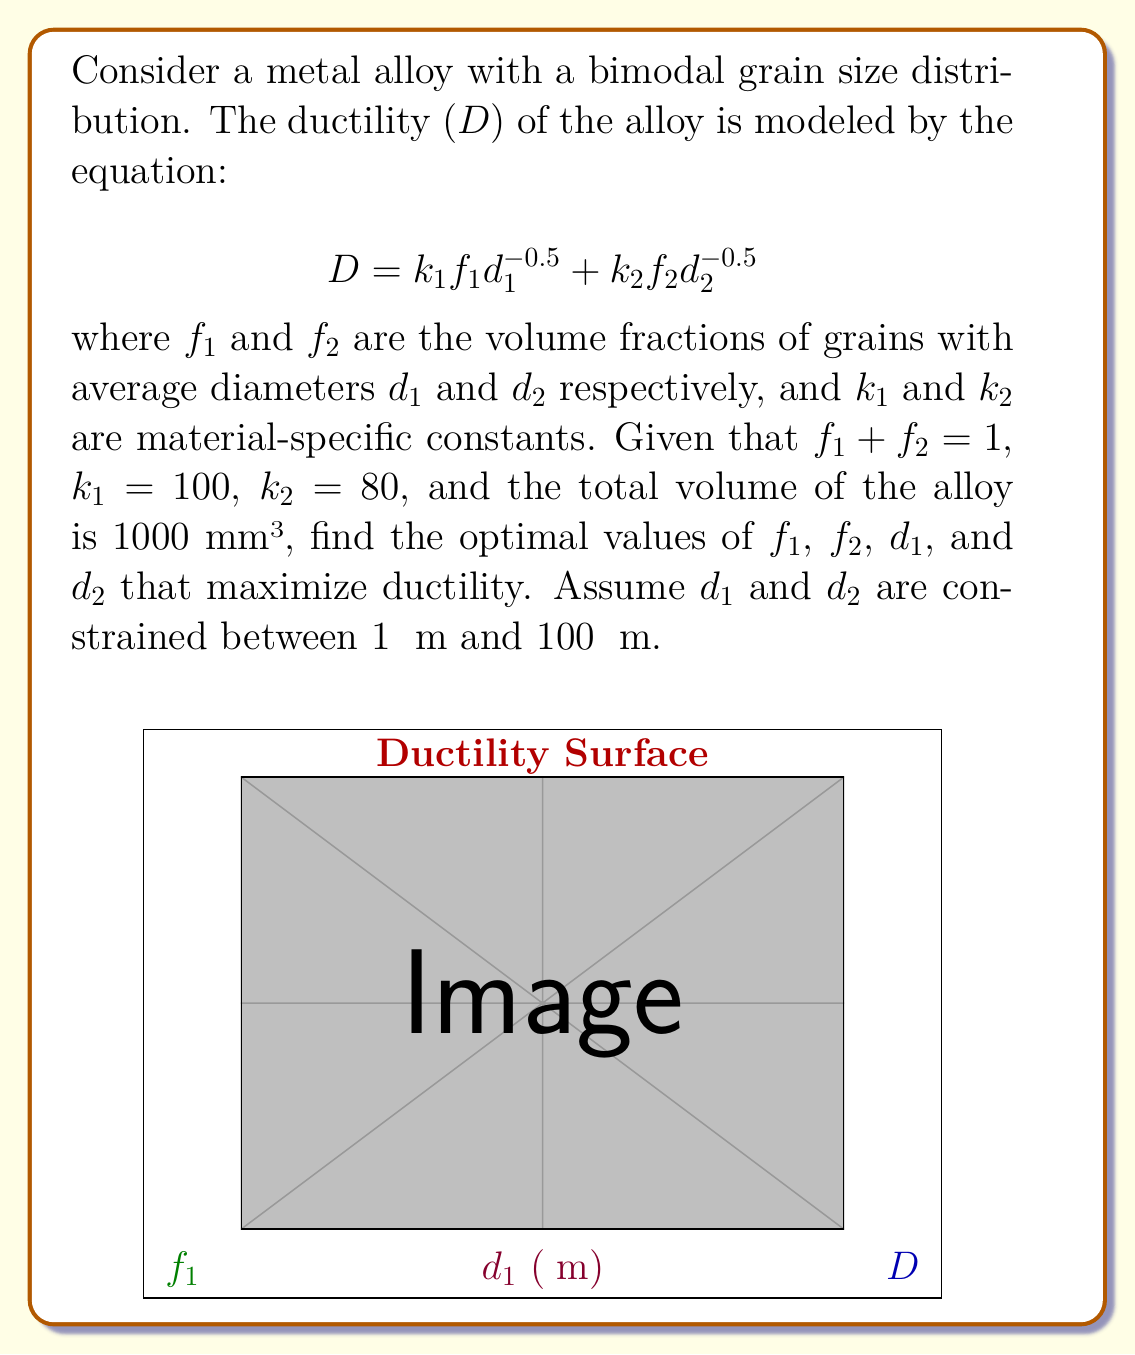Solve this math problem. To solve this optimization problem, we'll follow these steps:

1) First, we need to express the problem in terms of two variables. We can use $f_1$ and $d_1$, as $f_2 = 1 - f_1$ and we can set $d_2 = 100$ μm (the upper limit) to maximize the contribution of the second term.

2) Our objective function becomes:

   $$D = k_1f_1d_1^{-0.5} + k_2(1-f_1)(100)^{-0.5}$$

3) Substituting the given values:

   $$D = 100f_1d_1^{-0.5} + 80(1-f_1)/10$$

4) To find the maximum, we need to find where the partial derivatives with respect to $f_1$ and $d_1$ are both zero:

   $$\frac{\partial D}{\partial f_1} = 100d_1^{-0.5} - 8 = 0$$
   $$\frac{\partial D}{\partial d_1} = -50f_1d_1^{-1.5} = 0$$

5) From the second equation, we can see that $f_1$ must be 0 (which doesn't make sense in our context) or $d_1$ must approach infinity (which is outside our constraints). This means the maximum must occur at one of the boundaries for $d_1$.

6) Let's consider the two extreme cases for $d_1$:

   For $d_1 = 1$ μm: $D = 100f_1 + 8(1-f_1) = 92f_1 + 8$
   For $d_1 = 100$ μm: $D = 10f_1 + 8(1-f_1) = 2f_1 + 8$

7) The first case (d_1 = 1 μm) gives a higher value for D, so this is our optimal $d_1$.

8) Now we can solve for $f_1$:

   $100 * 1^{-0.5} - 8 = 0$
   $f_1 = 0.64$

9) Therefore, $f_2 = 1 - f_1 = 0.36$

10) To calculate the number of grains, we use the volume and the average grain volumes:

    $N_1 = \frac{0.64 * 1000}{(4/3)\pi(0.5)^3} \approx 1.22 * 10^9$
    $N_2 = \frac{0.36 * 1000}{(4/3)\pi(50)^3} \approx 137$
Answer: $f_1 = 0.64$, $f_2 = 0.36$, $d_1 = 1$ μm, $d_2 = 100$ μm, $N_1 \approx 1.22 * 10^9$, $N_2 \approx 137$ 